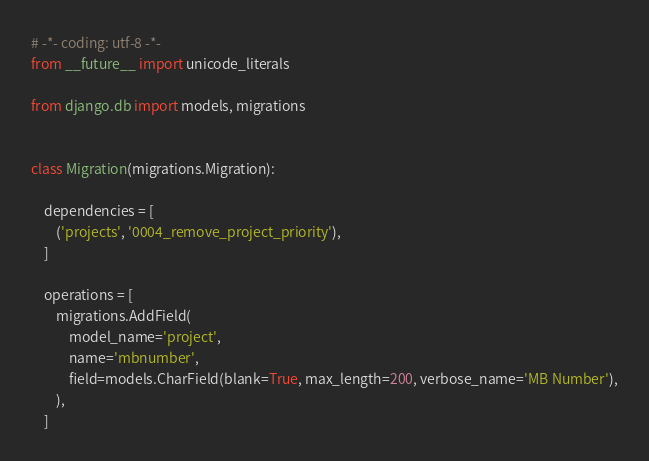Convert code to text. <code><loc_0><loc_0><loc_500><loc_500><_Python_># -*- coding: utf-8 -*-
from __future__ import unicode_literals

from django.db import models, migrations


class Migration(migrations.Migration):

    dependencies = [
        ('projects', '0004_remove_project_priority'),
    ]

    operations = [
        migrations.AddField(
            model_name='project',
            name='mbnumber',
            field=models.CharField(blank=True, max_length=200, verbose_name='MB Number'),
        ),
    ]
</code> 